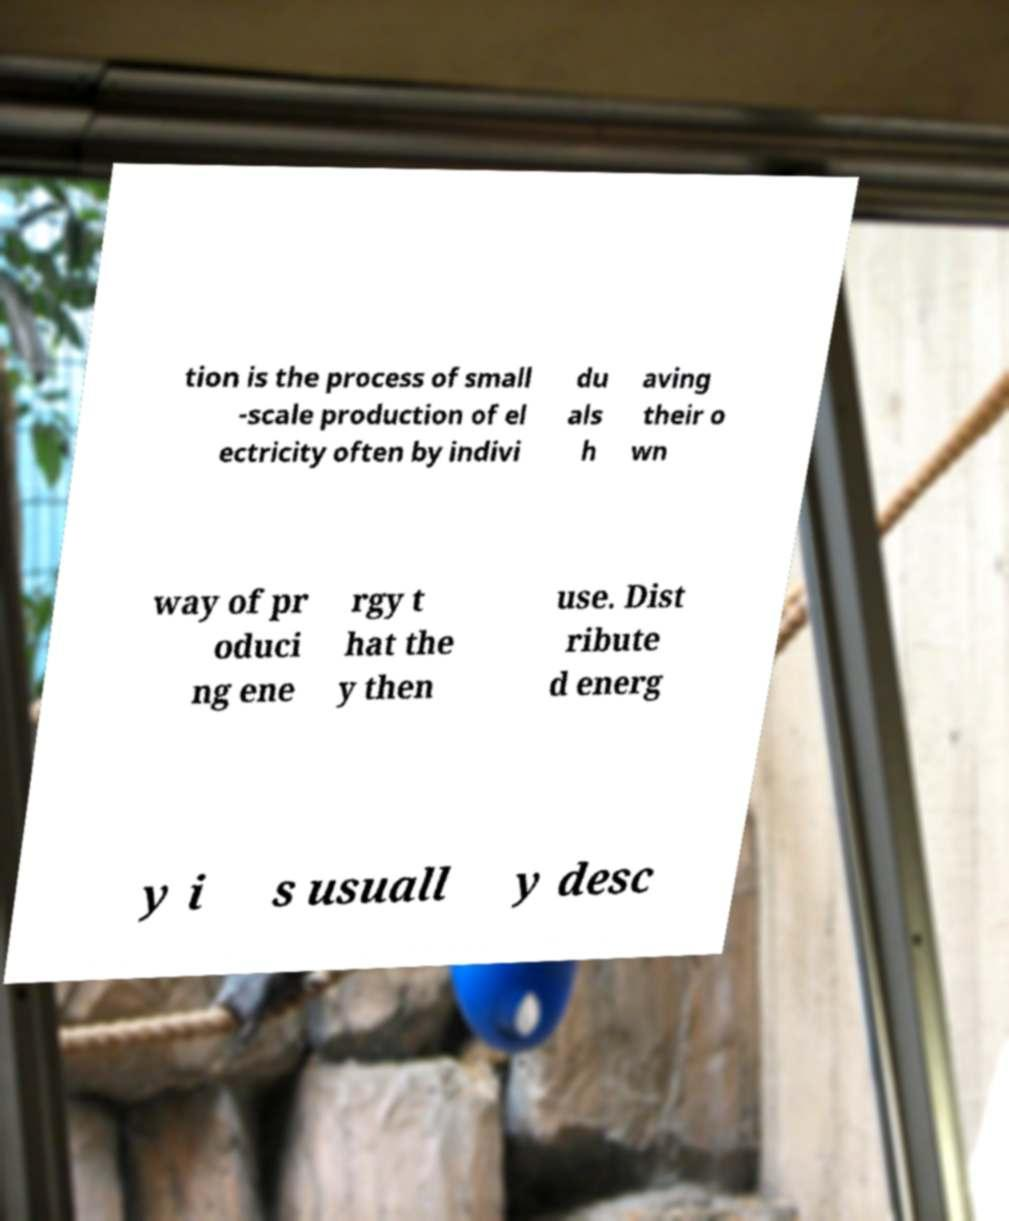Can you read and provide the text displayed in the image?This photo seems to have some interesting text. Can you extract and type it out for me? tion is the process of small -scale production of el ectricity often by indivi du als h aving their o wn way of pr oduci ng ene rgy t hat the y then use. Dist ribute d energ y i s usuall y desc 